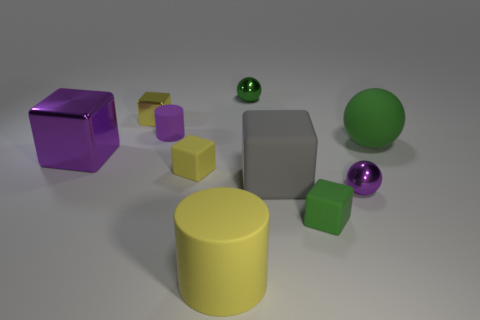Does the big green ball have the same material as the big purple block?
Provide a short and direct response. No. How big is the yellow thing that is in front of the tiny metallic thing that is right of the tiny cube that is right of the green metallic thing?
Provide a succinct answer. Large. What number of other things are the same color as the big ball?
Make the answer very short. 2. There is a green metallic thing that is the same size as the purple cylinder; what is its shape?
Offer a very short reply. Sphere. What number of tiny objects are green rubber balls or red cylinders?
Offer a terse response. 0. There is a shiny ball that is in front of the metal block right of the big purple block; is there a matte cube that is left of it?
Your answer should be very brief. Yes. Are there any green rubber objects that have the same size as the yellow shiny cube?
Your answer should be compact. Yes. There is a sphere that is the same size as the purple block; what is it made of?
Ensure brevity in your answer.  Rubber. There is a yellow metal cube; is it the same size as the purple shiny object that is to the left of the large yellow matte thing?
Your answer should be compact. No. What number of metallic things are green balls or small green blocks?
Make the answer very short. 1. 